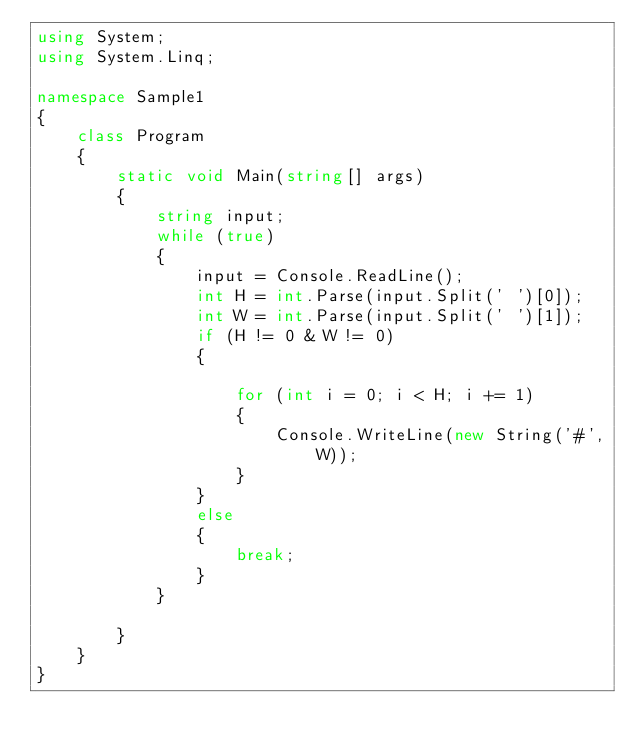<code> <loc_0><loc_0><loc_500><loc_500><_C#_>using System;
using System.Linq;

namespace Sample1
{
    class Program
    {
        static void Main(string[] args)
        {
            string input;
            while (true)
            {
                input = Console.ReadLine();
                int H = int.Parse(input.Split(' ')[0]);
                int W = int.Parse(input.Split(' ')[1]);
                if (H != 0 & W != 0)
                {

                    for (int i = 0; i < H; i += 1)
                    {
                        Console.WriteLine(new String('#', W));
                    }
                }
                else
                {
                    break;
                }
            }
            
        }
    }
}</code> 